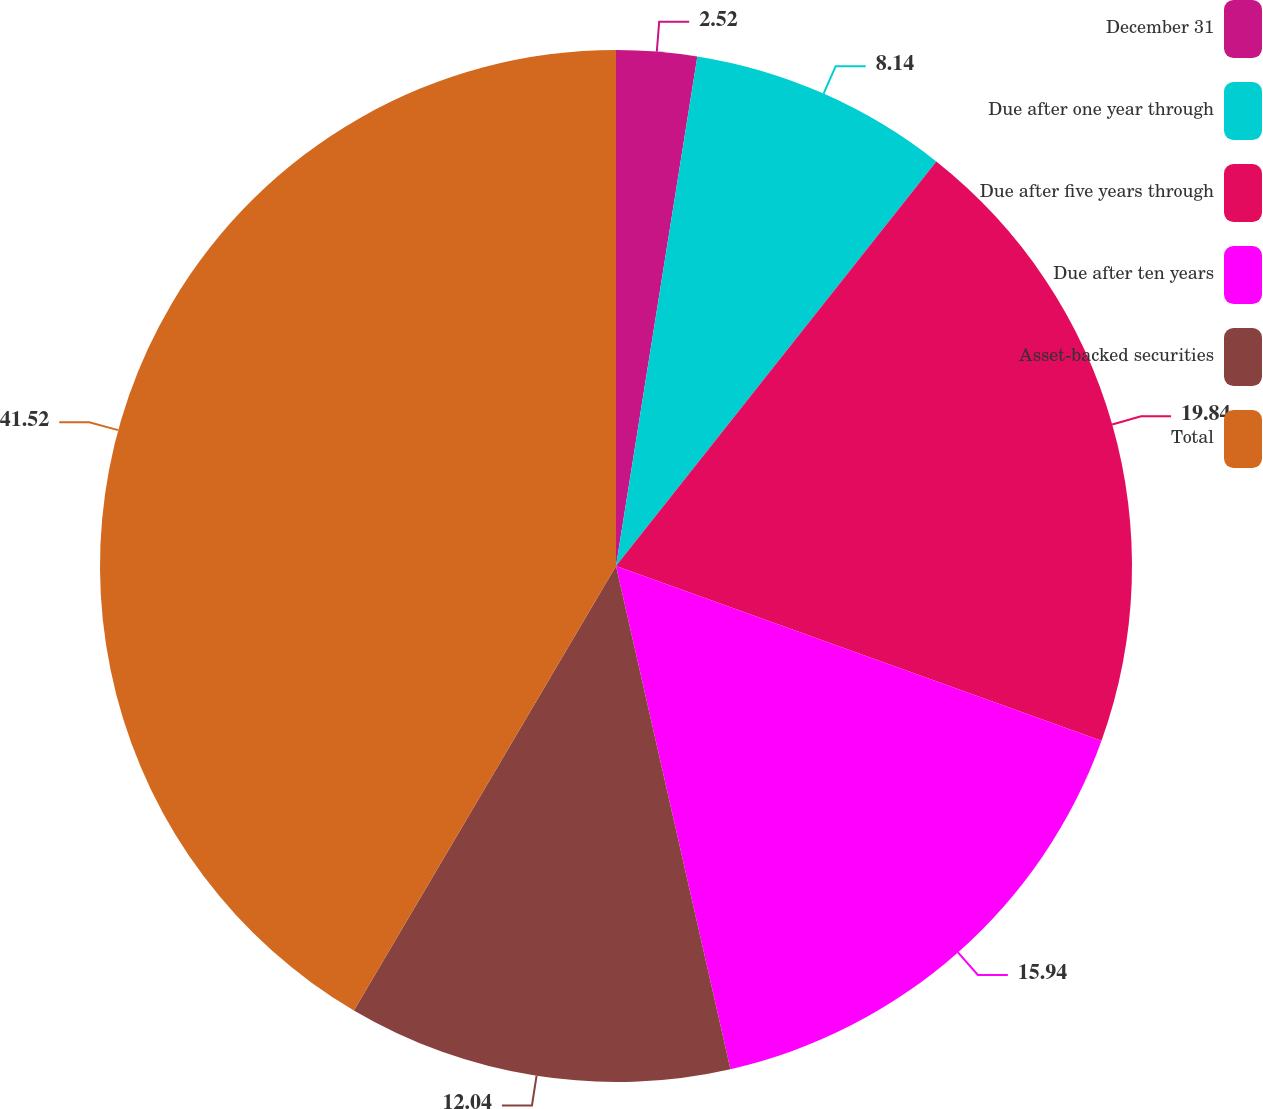<chart> <loc_0><loc_0><loc_500><loc_500><pie_chart><fcel>December 31<fcel>Due after one year through<fcel>Due after five years through<fcel>Due after ten years<fcel>Asset-backed securities<fcel>Total<nl><fcel>2.52%<fcel>8.14%<fcel>19.84%<fcel>15.94%<fcel>12.04%<fcel>41.52%<nl></chart> 